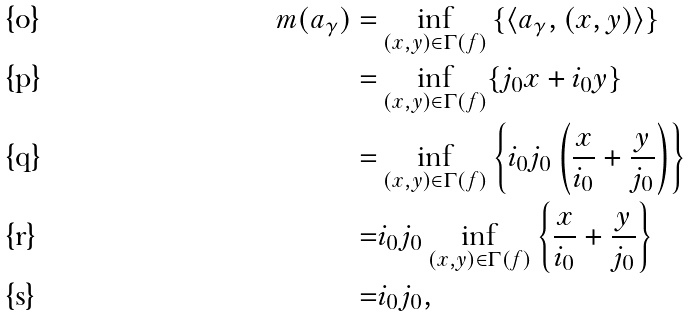<formula> <loc_0><loc_0><loc_500><loc_500>m ( a _ { \gamma } ) = & \inf _ { ( x , y ) \in \Gamma ( f ) } { \{ \langle a _ { \gamma } , ( x , y ) \rangle \} } \\ = & \inf _ { ( x , y ) \in \Gamma ( f ) } \{ j _ { 0 } x + i _ { 0 } y \} \\ = & \inf _ { ( x , y ) \in \Gamma ( f ) } \left \{ i _ { 0 } j _ { 0 } \left ( \frac { x } { i _ { 0 } } + \frac { y } { j _ { 0 } } \right ) \right \} \\ = & i _ { 0 } j _ { 0 } \inf _ { ( x , y ) \in \Gamma ( f ) } \left \{ \frac { x } { i _ { 0 } } + \frac { y } { j _ { 0 } } \right \} \\ = & i _ { 0 } j _ { 0 } ,</formula> 